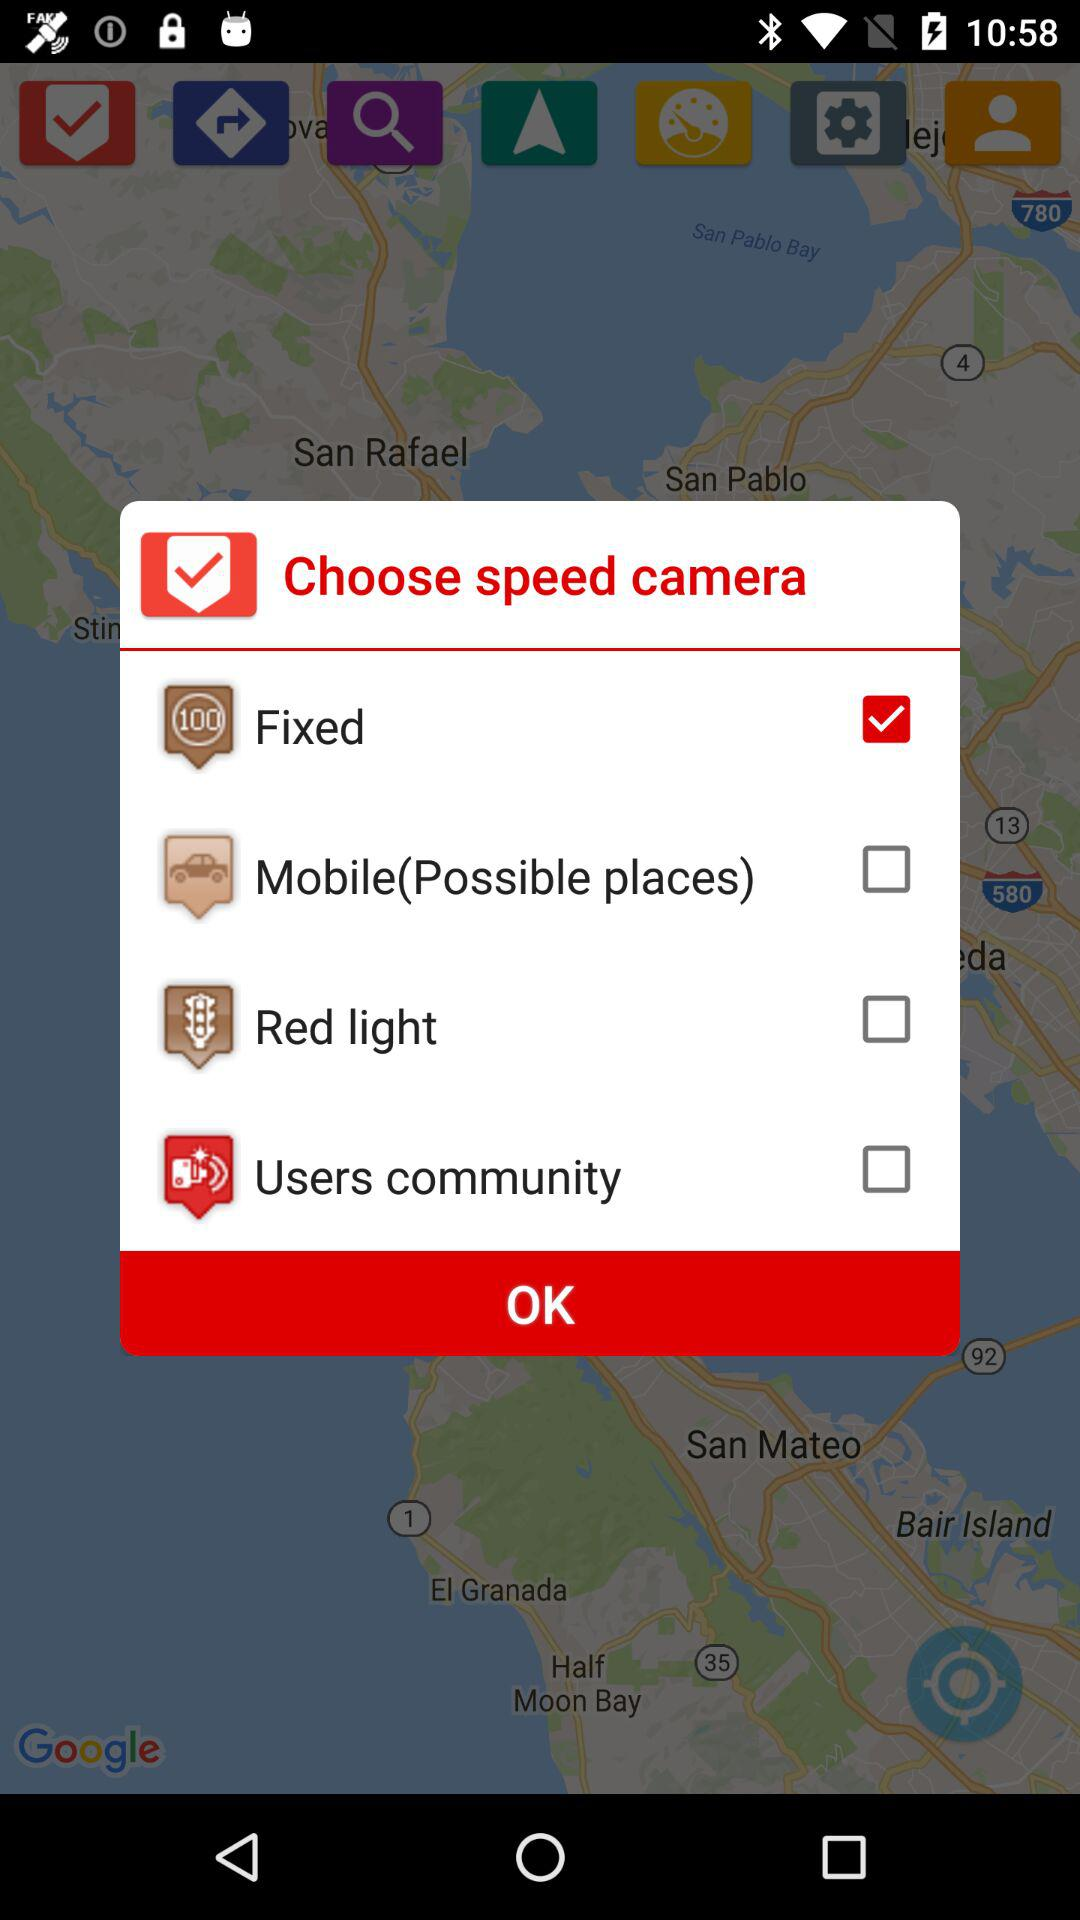Is "Fixed" checked or unchecked?
Answer the question using a single word or phrase. "Fixed" is checked. 